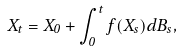Convert formula to latex. <formula><loc_0><loc_0><loc_500><loc_500>X _ { t } = X _ { 0 } + \int _ { 0 } ^ { t } f ( X _ { s } ) d B _ { s } ,</formula> 